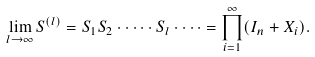<formula> <loc_0><loc_0><loc_500><loc_500>\lim _ { l \rightarrow \infty } S ^ { ( l ) } = S _ { 1 } S _ { 2 } \cdot \dots \cdot S _ { l } \cdot \dots = \prod _ { i = 1 } ^ { \infty } ( I _ { n } + X _ { i } ) .</formula> 